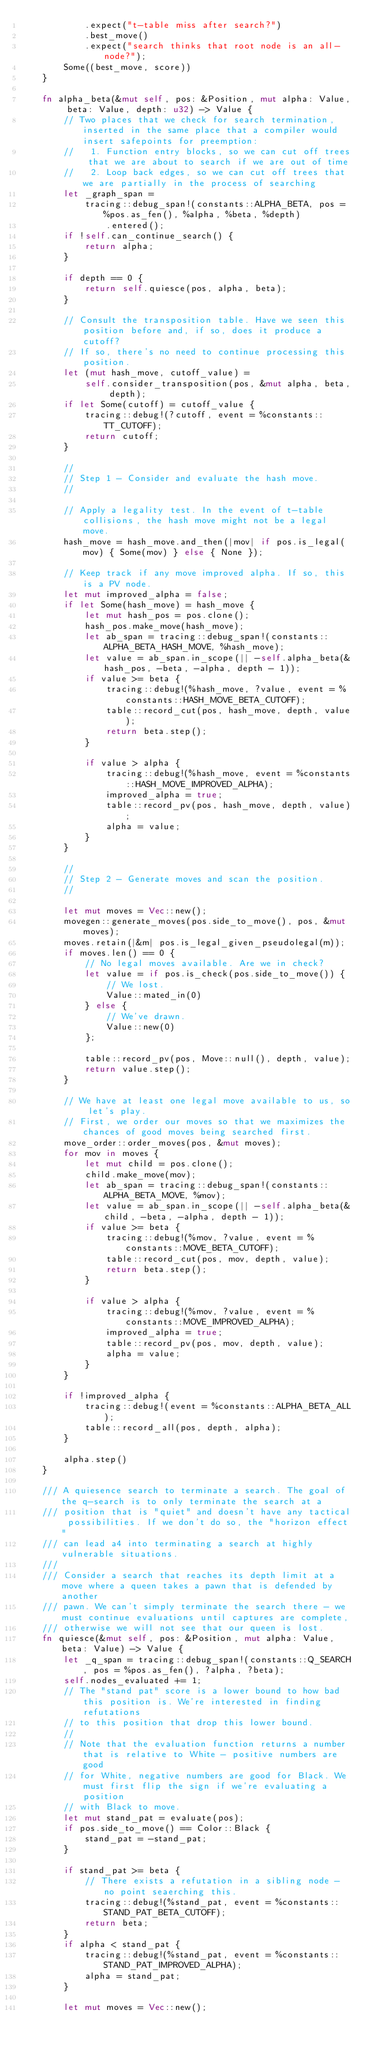<code> <loc_0><loc_0><loc_500><loc_500><_Rust_>            .expect("t-table miss after search?")
            .best_move()
            .expect("search thinks that root node is an all-node?");
        Some((best_move, score))
    }

    fn alpha_beta(&mut self, pos: &Position, mut alpha: Value, beta: Value, depth: u32) -> Value {
        // Two places that we check for search termination, inserted in the same place that a compiler would insert safepoints for preemption:
        //   1. Function entry blocks, so we can cut off trees that we are about to search if we are out of time
        //   2. Loop back edges, so we can cut off trees that we are partially in the process of searching
        let _graph_span =
            tracing::debug_span!(constants::ALPHA_BETA, pos = %pos.as_fen(), %alpha, %beta, %depth)
                .entered();
        if !self.can_continue_search() {
            return alpha;
        }

        if depth == 0 {
            return self.quiesce(pos, alpha, beta);
        }

        // Consult the transposition table. Have we seen this position before and, if so, does it produce a cutoff?
        // If so, there's no need to continue processing this position.
        let (mut hash_move, cutoff_value) =
            self.consider_transposition(pos, &mut alpha, beta, depth);
        if let Some(cutoff) = cutoff_value {
            tracing::debug!(?cutoff, event = %constants::TT_CUTOFF);
            return cutoff;
        }

        //
        // Step 1 - Consider and evaluate the hash move.
        //

        // Apply a legality test. In the event of t-table collisions, the hash move might not be a legal move.
        hash_move = hash_move.and_then(|mov| if pos.is_legal(mov) { Some(mov) } else { None });

        // Keep track if any move improved alpha. If so, this is a PV node.
        let mut improved_alpha = false;
        if let Some(hash_move) = hash_move {
            let mut hash_pos = pos.clone();
            hash_pos.make_move(hash_move);
            let ab_span = tracing::debug_span!(constants::ALPHA_BETA_HASH_MOVE, %hash_move);
            let value = ab_span.in_scope(|| -self.alpha_beta(&hash_pos, -beta, -alpha, depth - 1));
            if value >= beta {
                tracing::debug!(%hash_move, ?value, event = %constants::HASH_MOVE_BETA_CUTOFF);
                table::record_cut(pos, hash_move, depth, value);
                return beta.step();
            }

            if value > alpha {
                tracing::debug!(%hash_move, event = %constants::HASH_MOVE_IMPROVED_ALPHA);
                improved_alpha = true;
                table::record_pv(pos, hash_move, depth, value);
                alpha = value;
            }
        }

        //
        // Step 2 - Generate moves and scan the position.
        //

        let mut moves = Vec::new();
        movegen::generate_moves(pos.side_to_move(), pos, &mut moves);
        moves.retain(|&m| pos.is_legal_given_pseudolegal(m));
        if moves.len() == 0 {
            // No legal moves available. Are we in check?
            let value = if pos.is_check(pos.side_to_move()) {
                // We lost.
                Value::mated_in(0)
            } else {
                // We've drawn.
                Value::new(0)
            };

            table::record_pv(pos, Move::null(), depth, value);
            return value.step();
        }

        // We have at least one legal move available to us, so let's play.
        // First, we order our moves so that we maximizes the chances of good moves being searched first.
        move_order::order_moves(pos, &mut moves);
        for mov in moves {
            let mut child = pos.clone();
            child.make_move(mov);
            let ab_span = tracing::debug_span!(constants::ALPHA_BETA_MOVE, %mov);
            let value = ab_span.in_scope(|| -self.alpha_beta(&child, -beta, -alpha, depth - 1));
            if value >= beta {
                tracing::debug!(%mov, ?value, event = %constants::MOVE_BETA_CUTOFF);
                table::record_cut(pos, mov, depth, value);
                return beta.step();
            }

            if value > alpha {
                tracing::debug!(%mov, ?value, event = %constants::MOVE_IMPROVED_ALPHA);
                improved_alpha = true;
                table::record_pv(pos, mov, depth, value);
                alpha = value;
            }
        }

        if !improved_alpha {
            tracing::debug!(event = %constants::ALPHA_BETA_ALL);
            table::record_all(pos, depth, alpha);
        }

        alpha.step()
    }

    /// A quiesence search to terminate a search. The goal of the q-search is to only terminate the search at a
    /// position that is "quiet" and doesn't have any tactical possibilities. If we don't do so, the "horizon effect"
    /// can lead a4 into terminating a search at highly vulnerable situations.
    ///
    /// Consider a search that reaches its depth limit at a move where a queen takes a pawn that is defended by another
    /// pawn. We can't simply terminate the search there - we must continue evaluations until captures are complete,
    /// otherwise we will not see that our queen is lost.
    fn quiesce(&mut self, pos: &Position, mut alpha: Value, beta: Value) -> Value {
        let _q_span = tracing::debug_span!(constants::Q_SEARCH, pos = %pos.as_fen(), ?alpha, ?beta);
        self.nodes_evaluated += 1;
        // The "stand pat" score is a lower bound to how bad this position is. We're interested in finding refutations
        // to this position that drop this lower bound.
        //
        // Note that the evaluation function returns a number that is relative to White - positive numbers are good
        // for White, negative numbers are good for Black. We must first flip the sign if we're evaluating a position
        // with Black to move.
        let mut stand_pat = evaluate(pos);
        if pos.side_to_move() == Color::Black {
            stand_pat = -stand_pat;
        }

        if stand_pat >= beta {
            // There exists a refutation in a sibling node - no point seaerching this.
            tracing::debug!(%stand_pat, event = %constants::STAND_PAT_BETA_CUTOFF);
            return beta;
        }
        if alpha < stand_pat {
            tracing::debug!(%stand_pat, event = %constants::STAND_PAT_IMPROVED_ALPHA);
            alpha = stand_pat;
        }

        let mut moves = Vec::new();</code> 